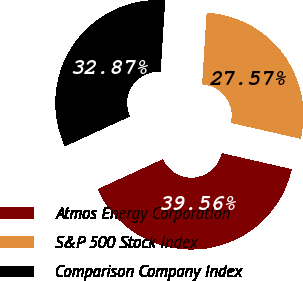<chart> <loc_0><loc_0><loc_500><loc_500><pie_chart><fcel>Atmos Energy Corporation<fcel>S&P 500 Stock Index<fcel>Comparison Company Index<nl><fcel>39.56%<fcel>27.57%<fcel>32.87%<nl></chart> 